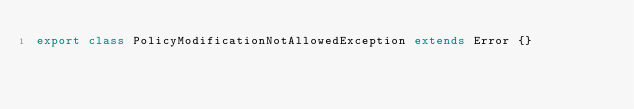Convert code to text. <code><loc_0><loc_0><loc_500><loc_500><_TypeScript_>export class PolicyModificationNotAllowedException extends Error {}
</code> 